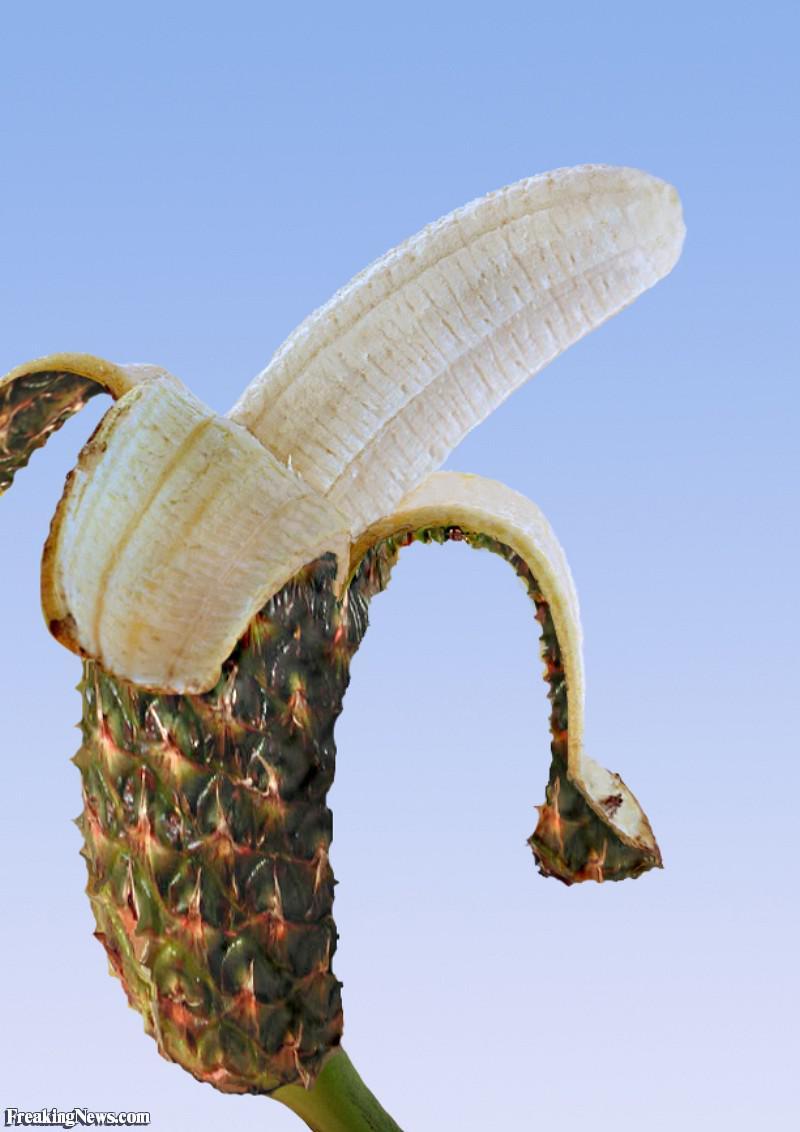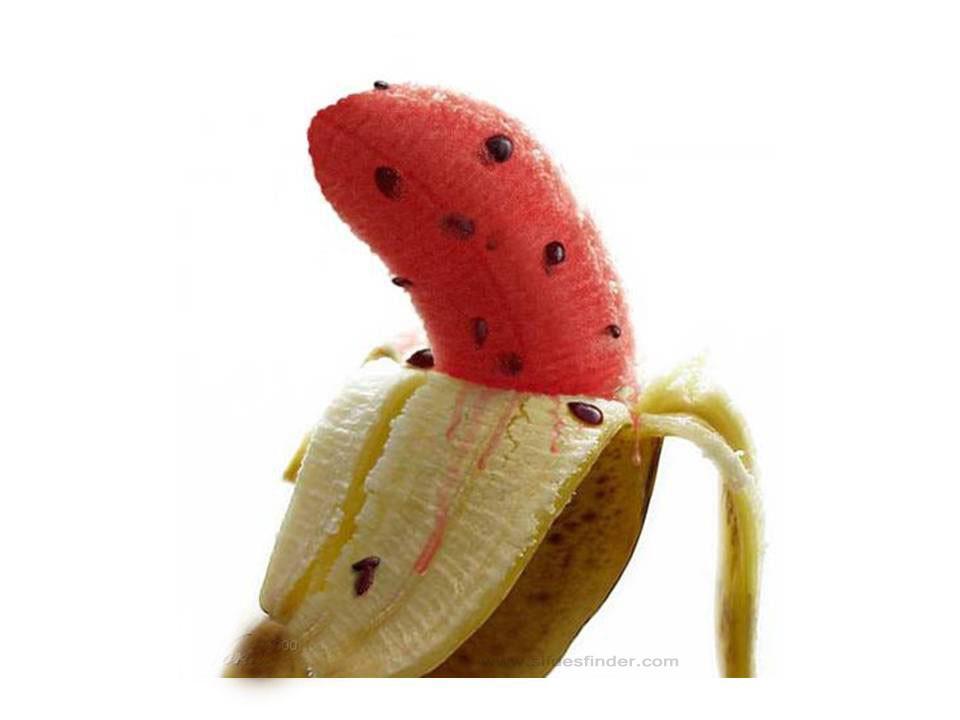The first image is the image on the left, the second image is the image on the right. Considering the images on both sides, is "The combined images include a pink-fleshed banana and a banana peel that resembles a different type of fruit." valid? Answer yes or no. Yes. 